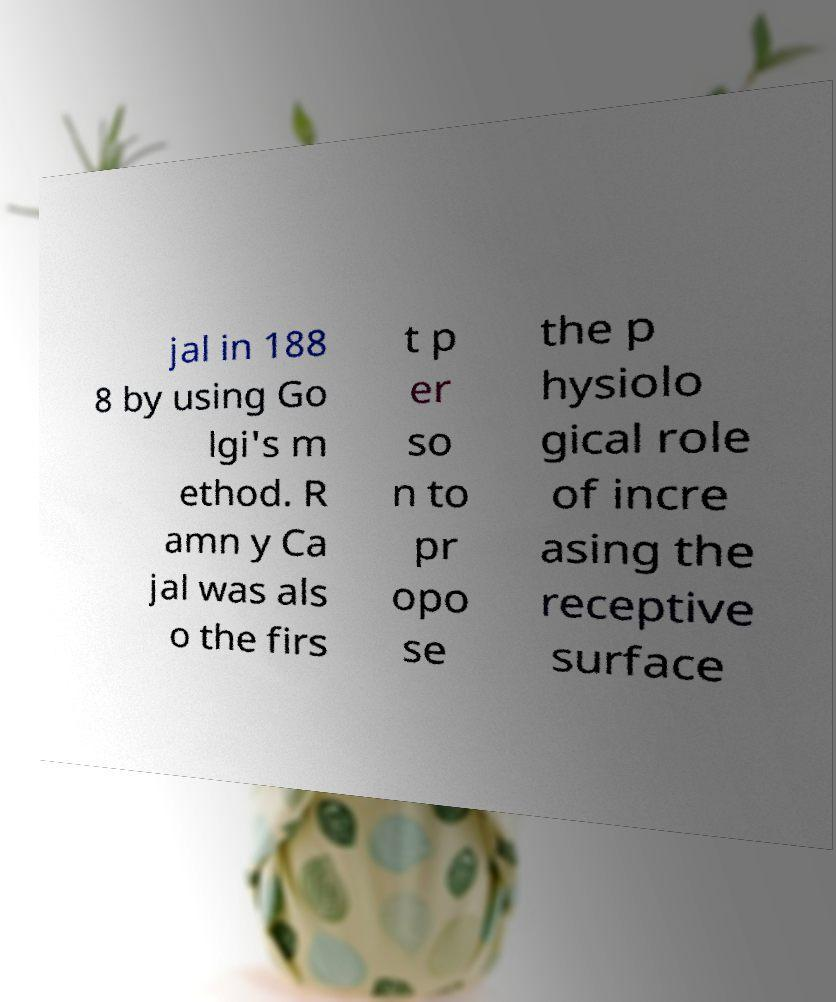I need the written content from this picture converted into text. Can you do that? jal in 188 8 by using Go lgi's m ethod. R amn y Ca jal was als o the firs t p er so n to pr opo se the p hysiolo gical role of incre asing the receptive surface 